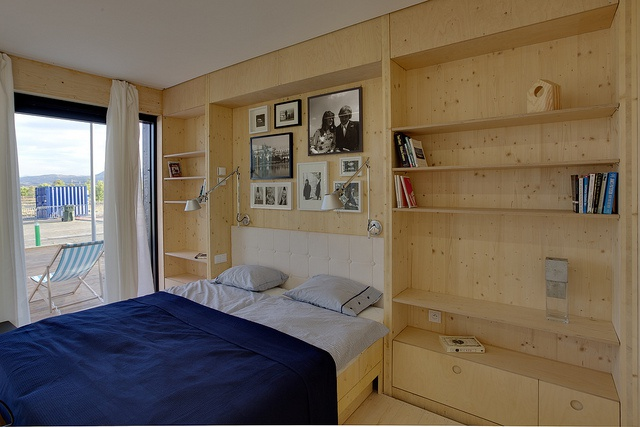Describe the objects in this image and their specific colors. I can see bed in gray, navy, and black tones, chair in gray and darkgray tones, book in gray, black, and blue tones, book in gray, olive, and black tones, and book in gray, maroon, brown, and darkgray tones in this image. 